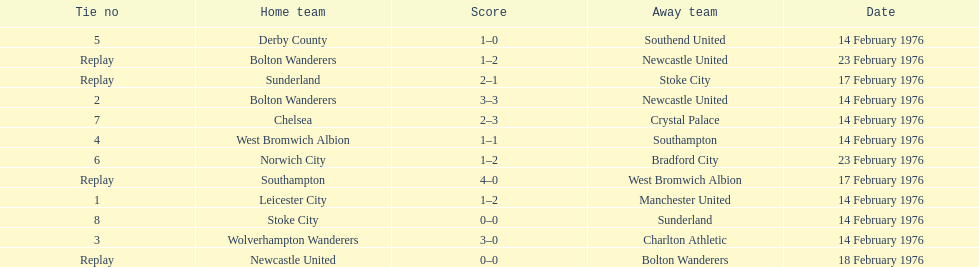What is the difference between southampton's score and sunderland's score? 2 goals. 